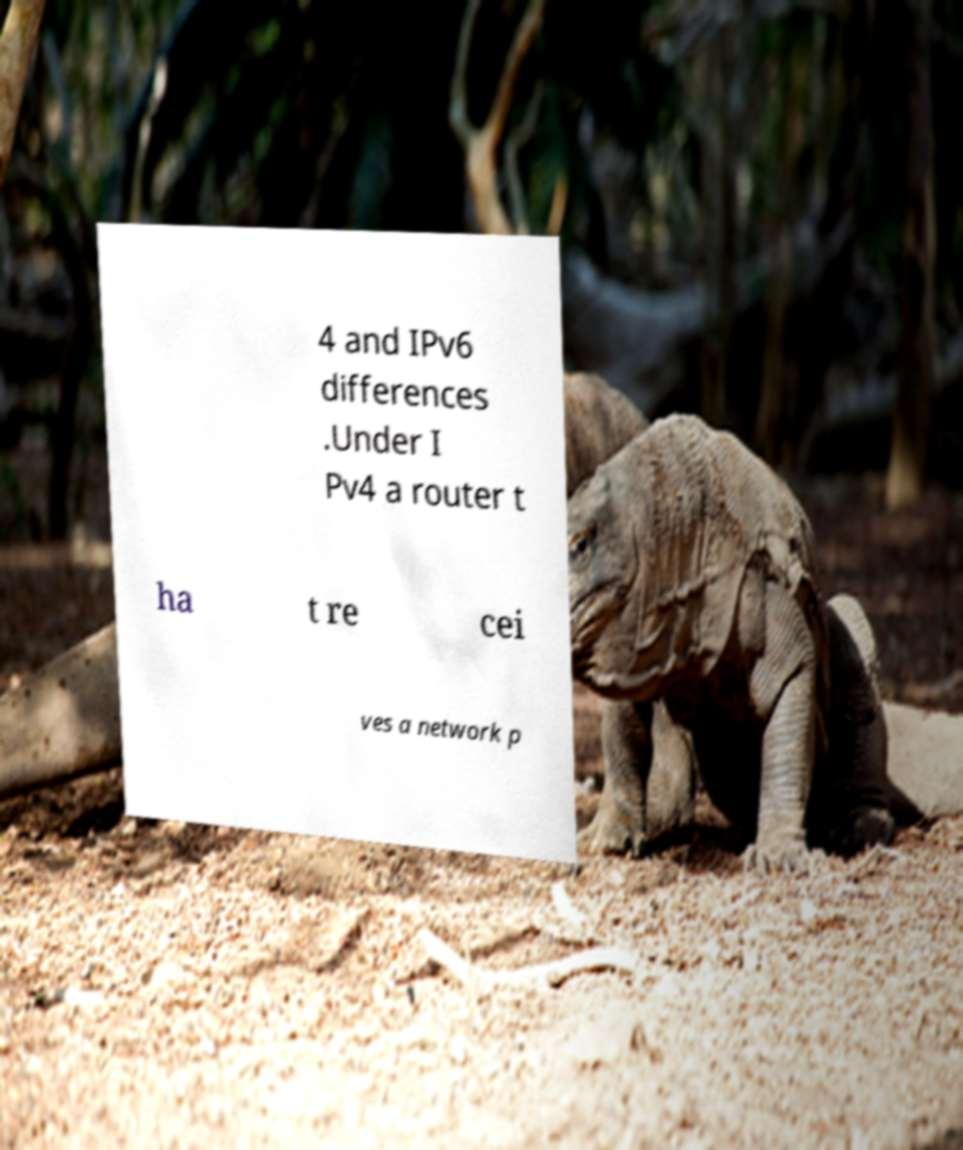I need the written content from this picture converted into text. Can you do that? 4 and IPv6 differences .Under I Pv4 a router t ha t re cei ves a network p 